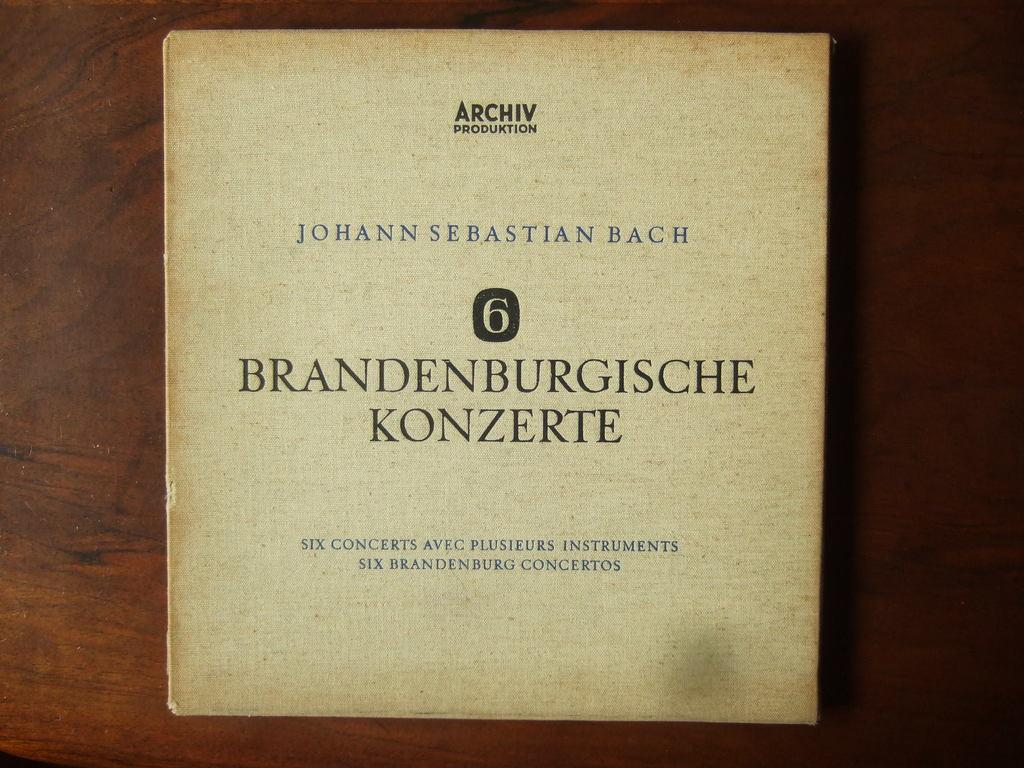<image>
Write a terse but informative summary of the picture. Brandenburgische konzerte book about six concerts aveg plus instruments 